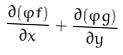Convert formula to latex. <formula><loc_0><loc_0><loc_500><loc_500>\frac { \partial ( \varphi f ) } { \partial x } + \frac { \partial ( \varphi g ) } { \partial y }</formula> 